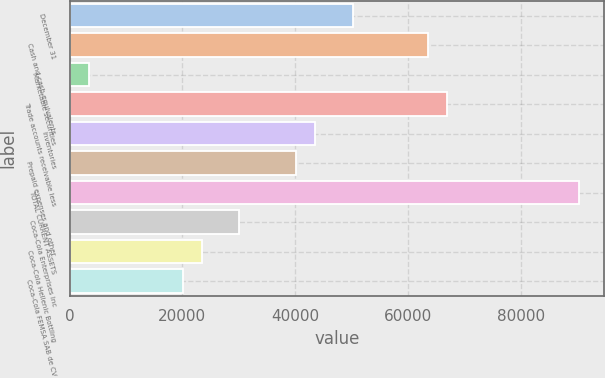Convert chart to OTSL. <chart><loc_0><loc_0><loc_500><loc_500><bar_chart><fcel>December 31<fcel>Cash and cash equivalents<fcel>Marketable securities<fcel>Trade accounts receivable less<fcel>Inventories<fcel>Prepaid expenses and other<fcel>TOTAL CURRENT ASSETS<fcel>Coca-Cola Enterprises Inc<fcel>Coca-Cola Hellenic Bottling<fcel>Coca-Cola FEMSA SAB de CV<nl><fcel>50185.5<fcel>63559.5<fcel>3376.5<fcel>66903<fcel>43498.5<fcel>40155<fcel>90307.5<fcel>30124.5<fcel>23437.5<fcel>20094<nl></chart> 